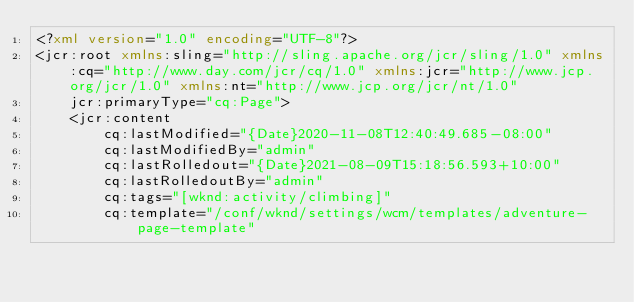<code> <loc_0><loc_0><loc_500><loc_500><_XML_><?xml version="1.0" encoding="UTF-8"?>
<jcr:root xmlns:sling="http://sling.apache.org/jcr/sling/1.0" xmlns:cq="http://www.day.com/jcr/cq/1.0" xmlns:jcr="http://www.jcp.org/jcr/1.0" xmlns:nt="http://www.jcp.org/jcr/nt/1.0"
    jcr:primaryType="cq:Page">
    <jcr:content
        cq:lastModified="{Date}2020-11-08T12:40:49.685-08:00"
        cq:lastModifiedBy="admin"
        cq:lastRolledout="{Date}2021-08-09T15:18:56.593+10:00"
        cq:lastRolledoutBy="admin"
        cq:tags="[wknd:activity/climbing]"
        cq:template="/conf/wknd/settings/wcm/templates/adventure-page-template"</code> 